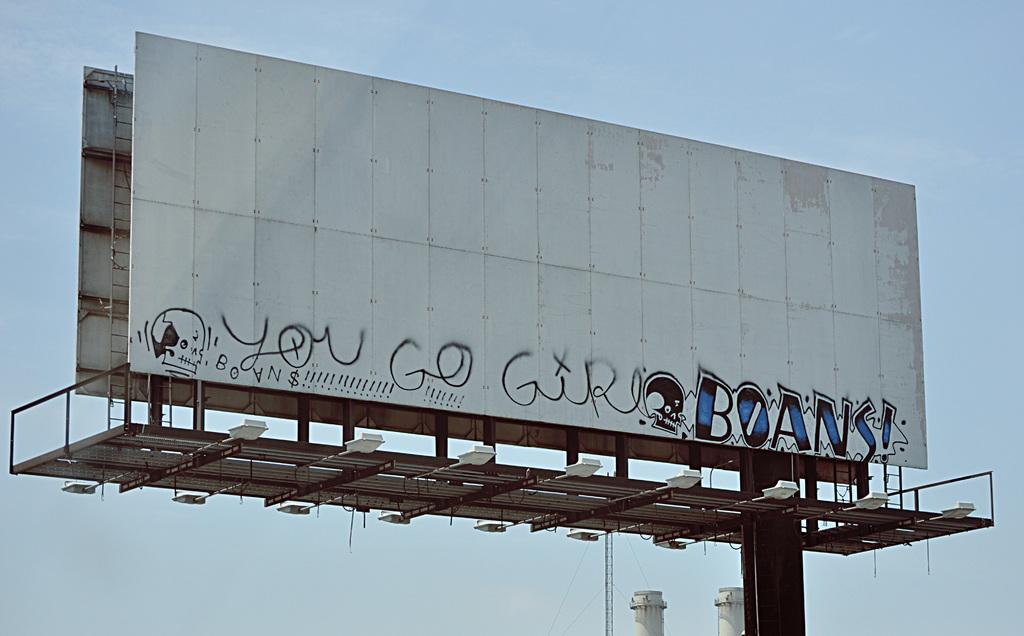<image>
Give a short and clear explanation of the subsequent image. A blank billboard bears graffiti saying you go girls and BOANS! 